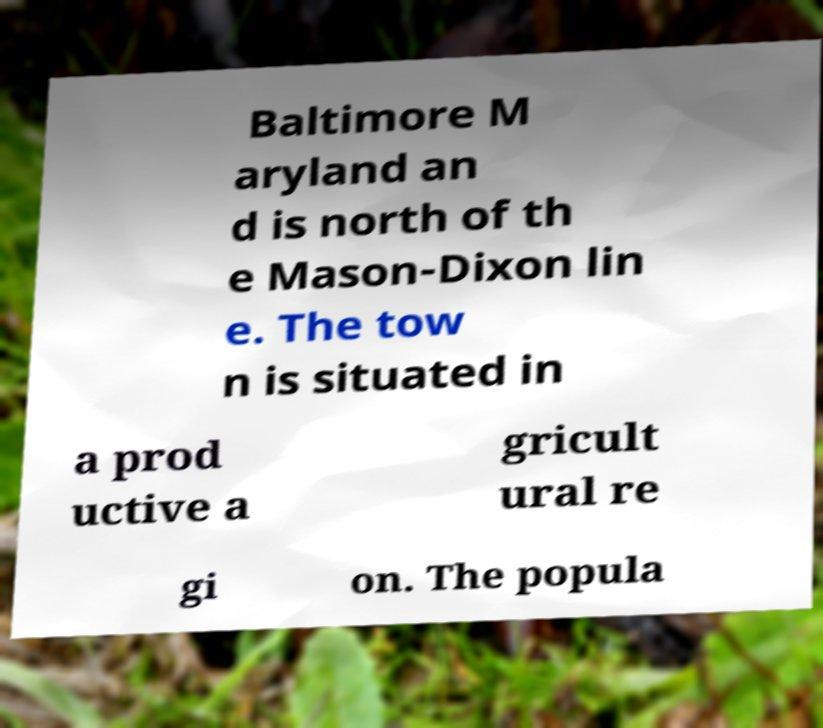Can you accurately transcribe the text from the provided image for me? Baltimore M aryland an d is north of th e Mason-Dixon lin e. The tow n is situated in a prod uctive a gricult ural re gi on. The popula 